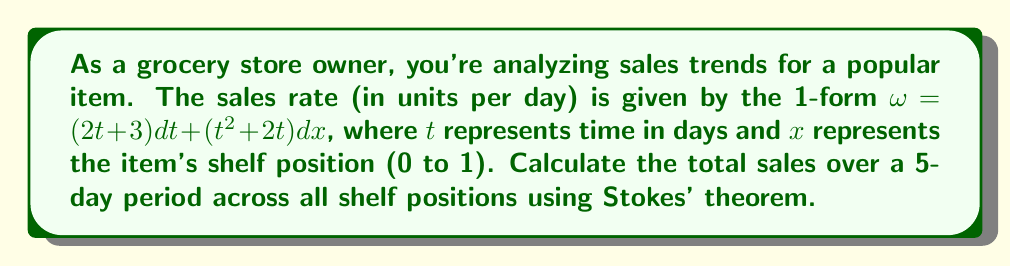Can you solve this math problem? To solve this problem, we'll follow these steps:

1) First, we need to identify the region of integration. It's a rectangle in the $t$-$x$ plane, where $0 \leq t \leq 5$ and $0 \leq x \leq 1$.

2) Stokes' theorem states that for a 1-form $\omega$ on a manifold $M$ with boundary $\partial M$:

   $$\int_{\partial M} \omega = \int_M d\omega$$

   where $d\omega$ is the exterior derivative of $\omega$.

3) We need to calculate $d\omega$:
   
   $d\omega = \frac{\partial}{\partial x}(2t + 3)dt \wedge dx + \frac{\partial}{\partial t}(t^2 + 2t)dt \wedge dx$
   
   $= (0 + (2t + 2))dt \wedge dx = (2t + 2)dt \wedge dx$

4) Now we can integrate $d\omega$ over the rectangle:

   $$\int_M d\omega = \int_0^5 \int_0^1 (2t + 2) dx dt$$

5) Evaluating the integral:

   $$\int_0^5 \int_0^1 (2t + 2) dx dt = \int_0^5 (2t + 2) dt = [t^2 + 2t]_0^5 = 25 + 10 = 35$$

6) Therefore, the total sales over the 5-day period across all shelf positions is 35 units.
Answer: 35 units 